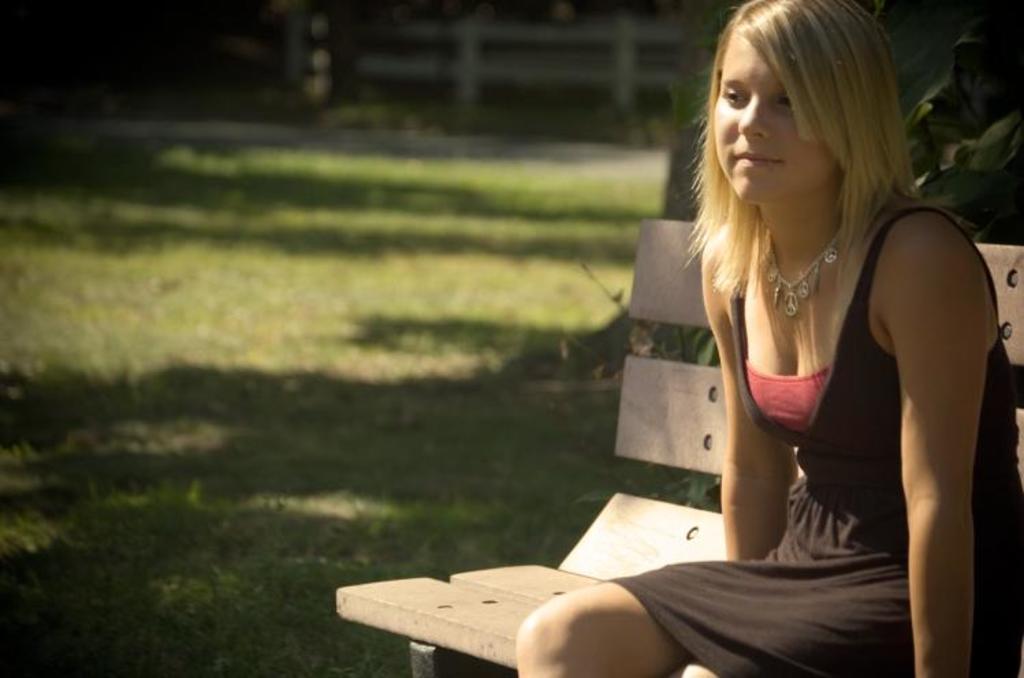Could you give a brief overview of what you see in this image? In this image woman is sitting on the bench in the garden. 